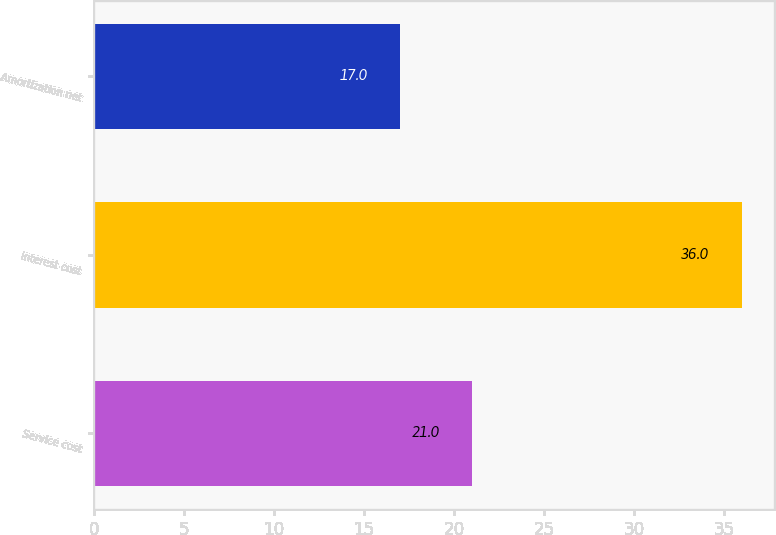Convert chart to OTSL. <chart><loc_0><loc_0><loc_500><loc_500><bar_chart><fcel>Service cost<fcel>Interest cost<fcel>Amortization net<nl><fcel>21<fcel>36<fcel>17<nl></chart> 